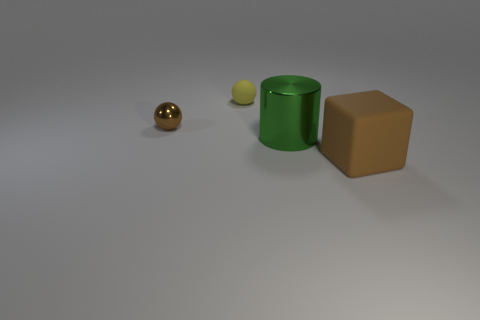Which object in the image is closest to the camera? The object closest to the camera is the shiny, reflective sphere with a golden color. What material does the sphere look like it's made of? The sphere’s reflective surface and golden tint suggest it is made of a polished metal, possibly gold or brass. 